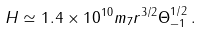Convert formula to latex. <formula><loc_0><loc_0><loc_500><loc_500>H \simeq 1 . 4 \times 1 0 ^ { 1 0 } m _ { 7 } r ^ { 3 / 2 } \Theta _ { - 1 } ^ { 1 / 2 } \, .</formula> 